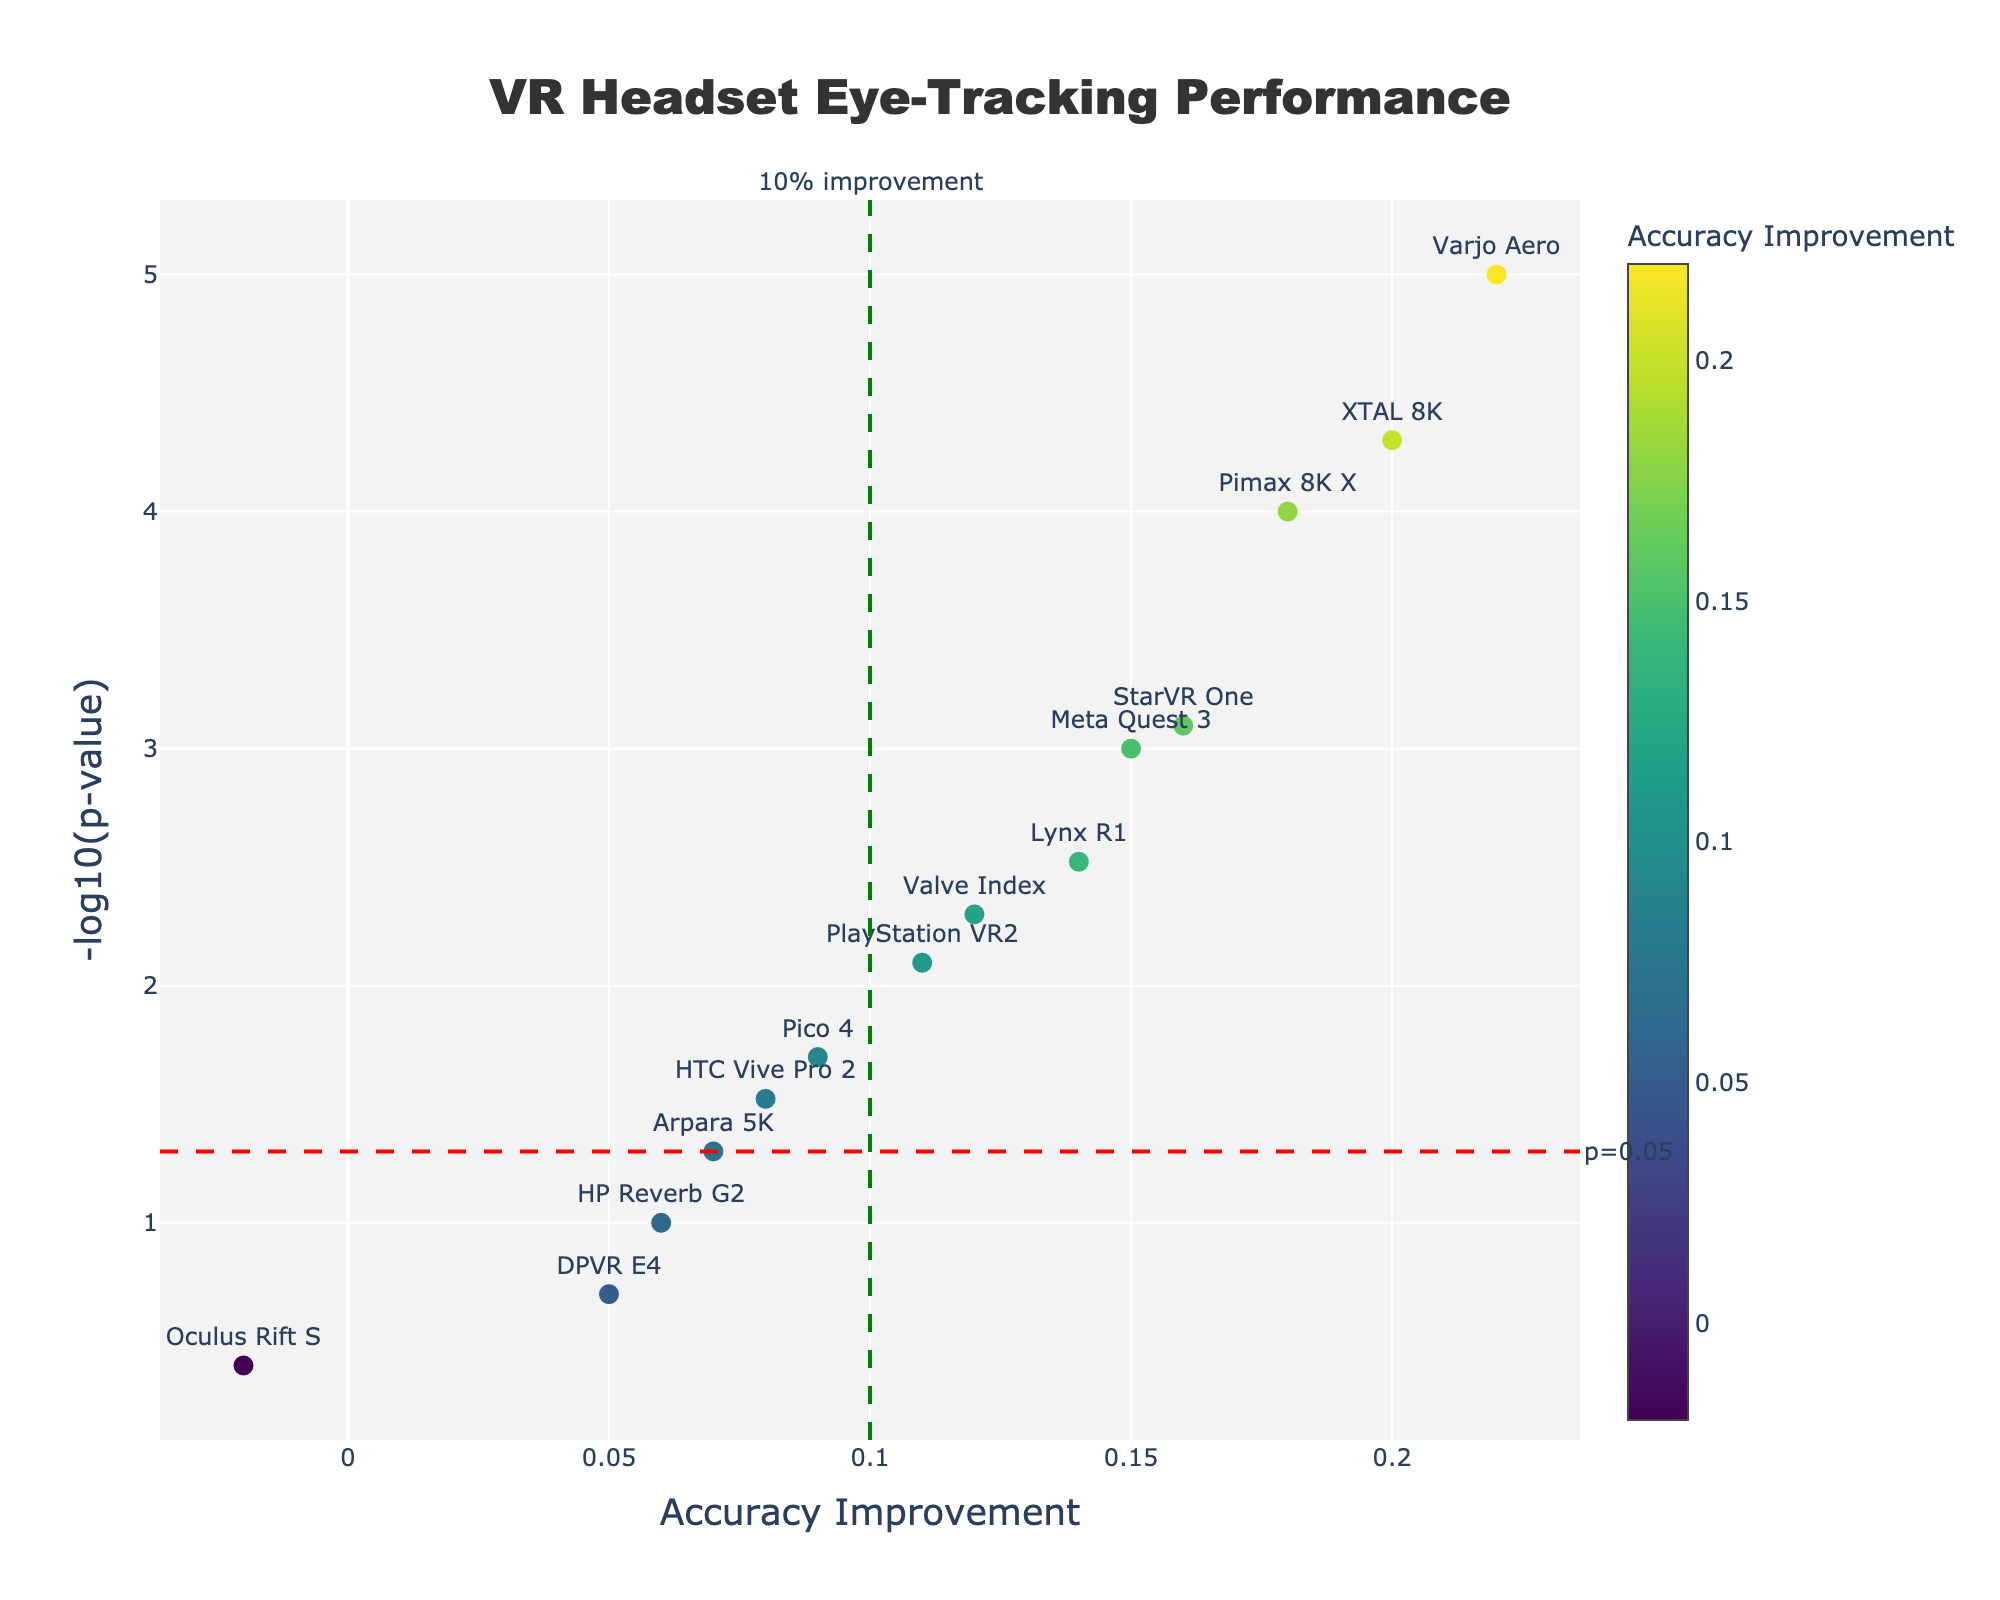what is the title of the plot? The title of the plot is located at the top center of the figure and generally provides a summary of the plot's content.
Answer: VR Headset Eye-Tracking Performance how many headsets had a statistically significant p-value below 0.05? To find the number of headsets with a statistically significant p-value below 0.05, check all data points with a y-value greater than -log10(0.05), based on the horizontal threshold line marked in the figure. Count these points.
Answer: 11 which headset shows the highest accuracy improvement, and what is its p-value? Look for the data point that is farthest to the right on the x-axis and read the corresponding text label to determine the headset model. Then, note its p-value, which will be provided in the hover text.
Answer: Varjo Aero, 0.00001 which headset has the lowest accuracy improvement? Identify the data point that is farthest to the left on the x-axis and read the corresponding text label to determine the headset model.
Answer: Oculus Rift S what accuracy improvement is indicated by the green vertical threshold line? The position of the green vertical line on the x-axis provides the threshold for accuracy improvement. Read the value on the x-axis where the line is drawn.
Answer: 0.1 how many headsets show an accuracy improvement greater than 0.1 with a p-value below 0.05? Identify the points above the horizontal threshold line at -log10(0.05) and to the right of the vertical threshold line at 0.1. Count these points.
Answer: 7 which two headsets have similar accuracy improvements but different statistical significances? Look for data points that are close to each other on the x-axis (accuracy improvement) but have significant differences along the y-axis (-log10(p-value)). Read the text labels to determine the headset models.
Answer: Valve Index and PlayStation VR2 comparing the HTC Vive Pro 2 and Meta Quest 3, which has a higher accuracy improvement and what's the difference in their p-values? Locate the points for HTC Vive Pro 2 and Meta Quest 3 on the plot. Compare their x-values to see which is higher and subtract one p-value from the other.
Answer: Meta Quest 3, 0.029 how does the accuracy improvement for HP Reverb G2 compare to the 10% improvement threshold? Locate the HP Reverb G2 point on the plot and compare its x-value against the vertical threshold line at 0.1 to see if it is greater or lesser.
Answer: Less 